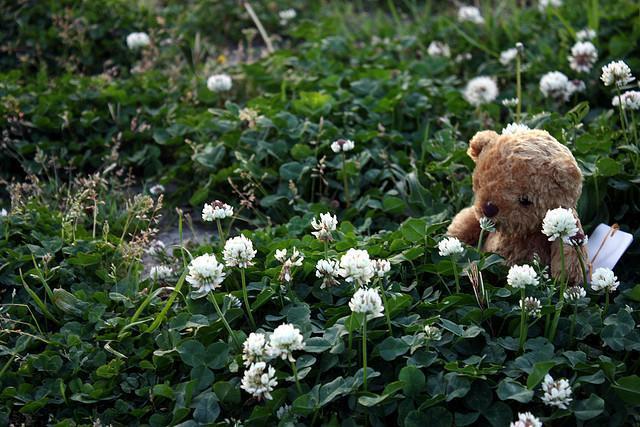How many teddy bears are in the picture?
Give a very brief answer. 1. How many people can sit at this meal?
Give a very brief answer. 0. 